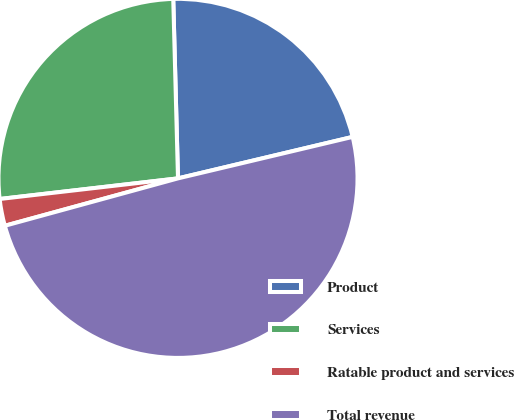Convert chart. <chart><loc_0><loc_0><loc_500><loc_500><pie_chart><fcel>Product<fcel>Services<fcel>Ratable product and services<fcel>Total revenue<nl><fcel>21.71%<fcel>26.41%<fcel>2.42%<fcel>49.46%<nl></chart> 